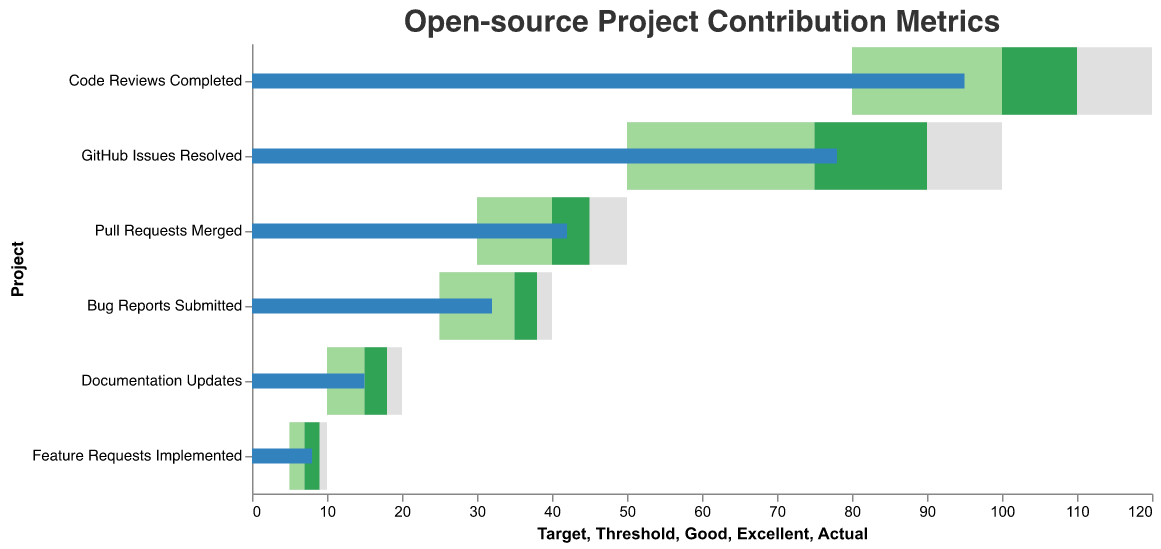What is the title of the chart? The title is usually displayed at the top of the chart. In this case, the title is "Open-source Project Contribution Metrics".
Answer: Open-source Project Contribution Metrics Which project has the highest actual contributions? By comparing the actual contributions across all projects (indicated by the blue bars), "Code Reviews Completed" has the highest actual value of 95.
Answer: Code Reviews Completed What is the excellent threshold for 'Pull Requests Merged'? Locate the "Pull Requests Merged" row, and find the value corresponding to the excellent category (indicated by the dark green).
Answer: 45 How many projects have an actual contribution that is below their threshold level? For each project, check if the actual contribution value (blue bar) is below the threshold value (light grey). "Documentation Updates" and "Feature Requests Implemented" fall below their thresholds.
Answer: 2 What is the difference between the actual and target contributions for 'Bug Reports Submitted'? Subtract the actual value of "Bug Reports Submitted" (32) from its target value (40).
Answer: 8 Which projects have achieved at least the good threshold in their contributions? Verify if the blue bar (actual contribution) is equal to or exceeds the light green bar (good threshold) for each project. "GitHub Issues Resolved", "Pull Requests Merged", "Code Reviews Completed", and "Bug Reports Submitted" qualify.
Answer: 4 How does 'Documentation Updates' compare to its target contributions? For "Documentation Updates", compare the actual contributions (15) to the target (20). The actual contributions are below the target.
Answer: Below Is 'Code Reviews Completed' exceeding the excellent threshold? The actual contributions for "Code Reviews Completed" (95) are below the excellent threshold (110).
Answer: No Which project is closest to meeting its target contributions? Calculate the difference between actual and target contributions for each project. "Pull Requests Merged" has the smallest difference (8).
Answer: Pull Requests Merged What color represents the excellent category in this chart? The excellent category is marked with a dark green color.
Answer: Dark Green 